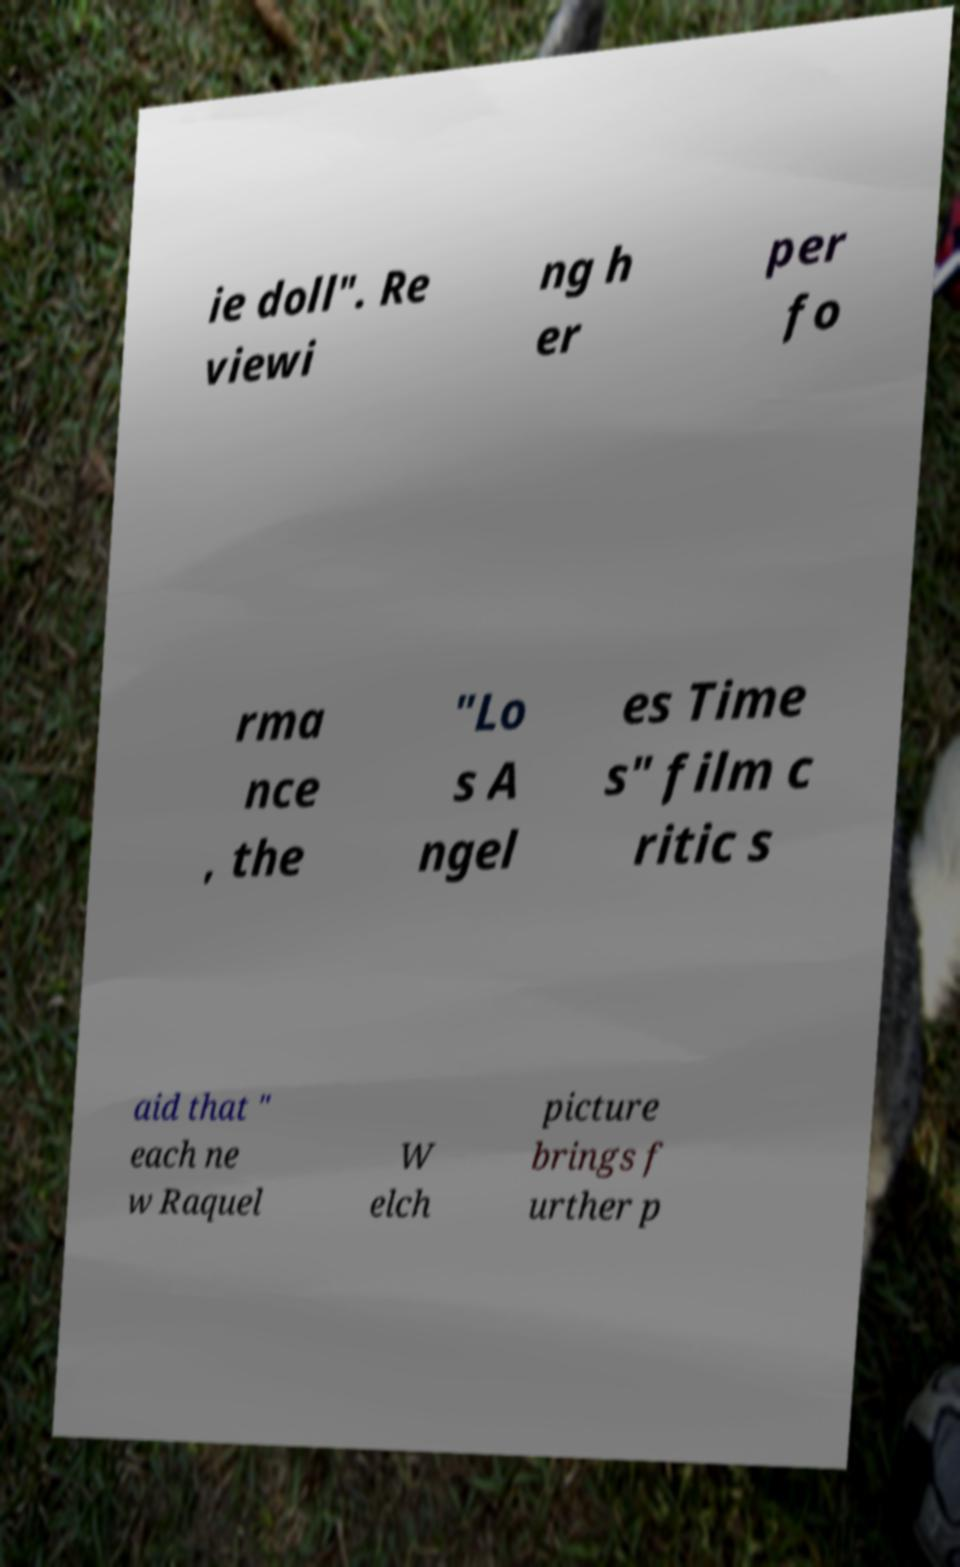What messages or text are displayed in this image? I need them in a readable, typed format. ie doll". Re viewi ng h er per fo rma nce , the "Lo s A ngel es Time s" film c ritic s aid that " each ne w Raquel W elch picture brings f urther p 